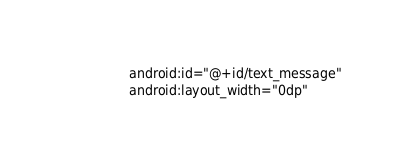Convert code to text. <code><loc_0><loc_0><loc_500><loc_500><_XML_>                android:id="@+id/text_message"
                android:layout_width="0dp"</code> 